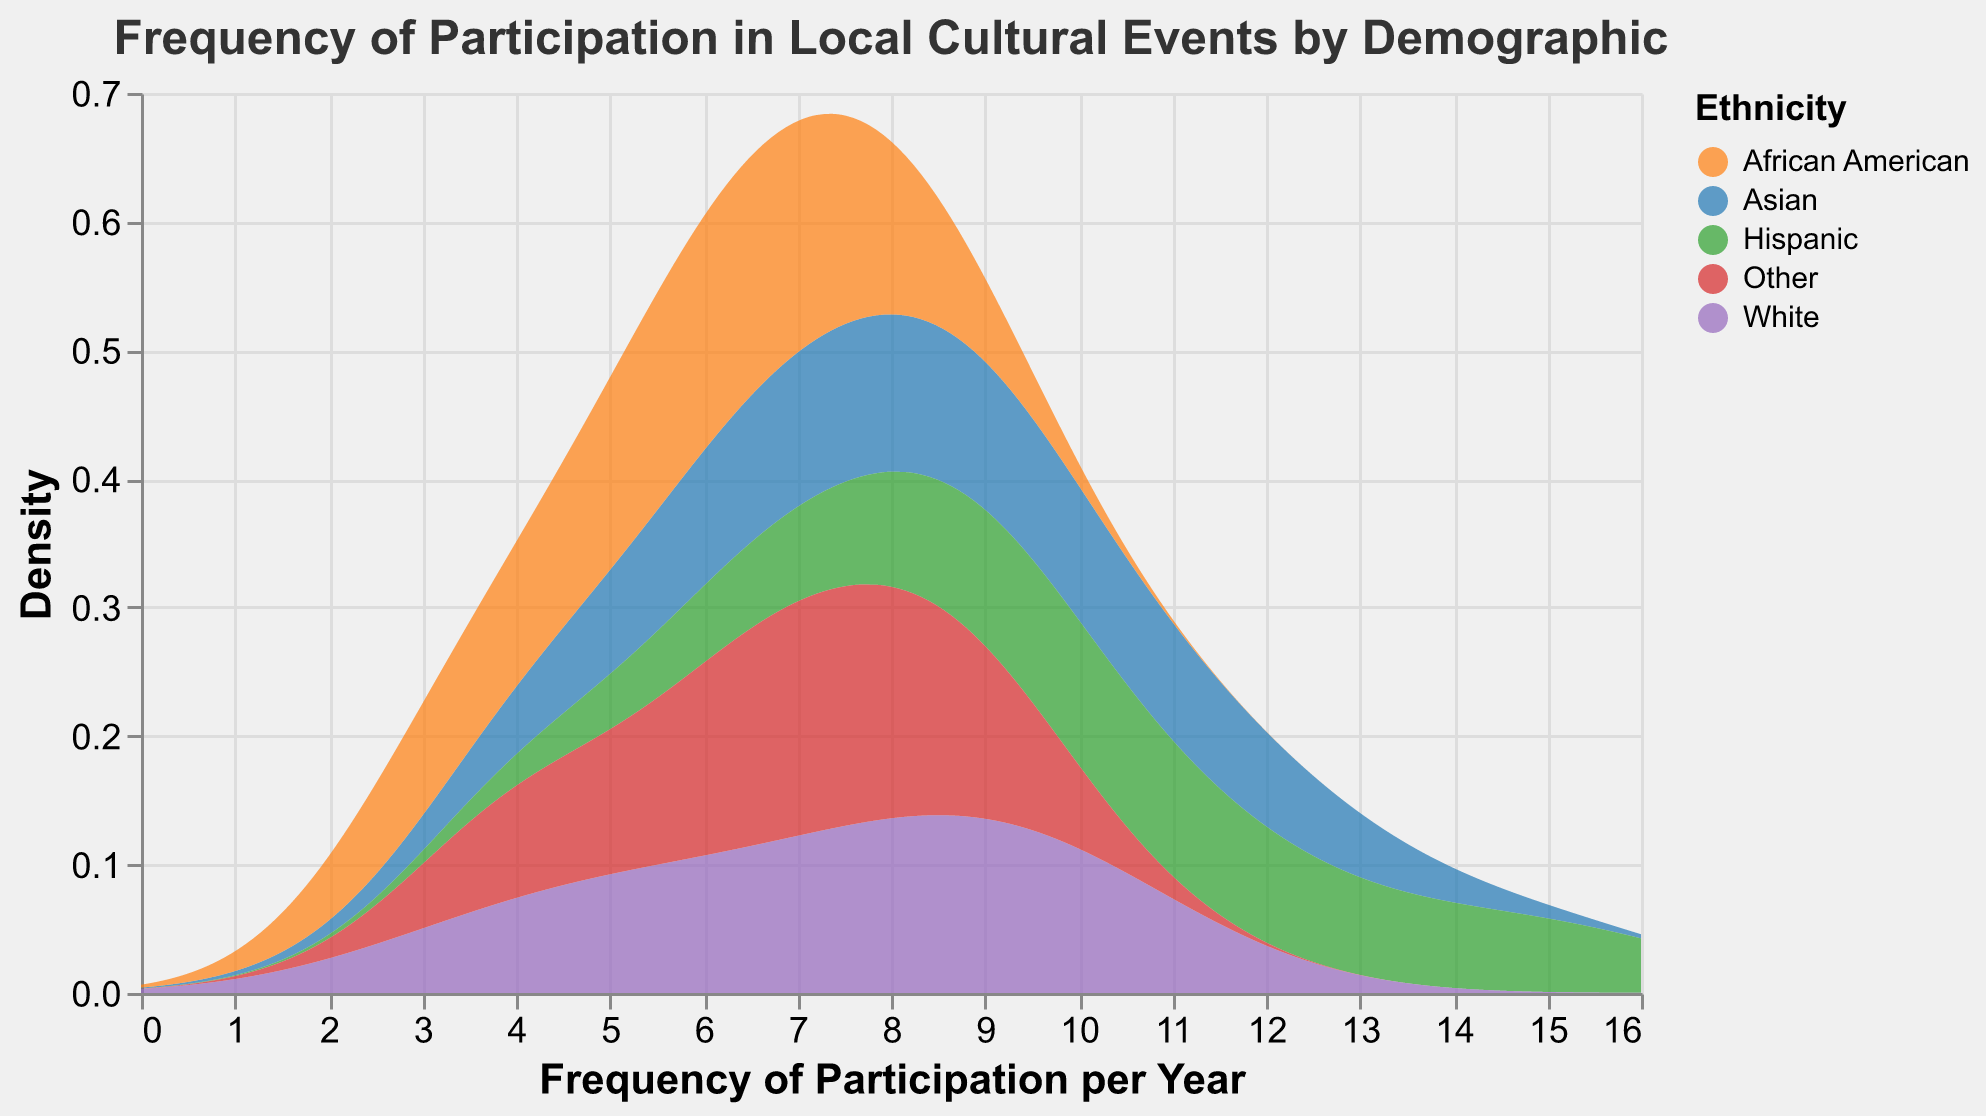What is the title of the plot? The title is at the top of the plot and reads "Frequency of Participation in Local Cultural Events by Demographic".
Answer: Frequency of Participation in Local Cultural Events by Demographic Which ethnic group appears to have the highest peak density in the plot? By examining the height of the peaks in the density plot, we can see that the Hispanic group has the highest peak density.
Answer: Hispanic What is the range of Frequency of Participation per Year shown on the x-axis? The x-axis represents "Frequency of Participation per Year," and the extent covers values from 0 to 16.
Answer: 0 to 16 How does the density distribution of African Americans differ from Asians in terms of frequency participation? The density distribution for African Americans peaks at a lower frequency and has generally lower density values compared to Asians, whose distribution peaks at a higher frequency.
Answer: African Americans peak lower than Asians Which age group shows the highest frequency of participation within the Hispanic ethnicity? By looking at the data points and their distribution in the plot, the age group 26-35 within the Hispanic ethnicity category shows the highest frequency of participation.
Answer: 26-35 Between which age groups is the decline in frequency of participation the steepest in the White ethnicity category? The data shows a significant drop-off between the 26-35 and the 36-45 age groups and then an even steeper decline between 46-60 and 61+.
Answer: 46-60 to 61+ What can you infer about the frequency of participation for those aged 61+ across all ethnicities? The plot shows that the density and frequency of participation for the 61+ age group are the lowest across all ethnicities, indicating reduced participation in this age group.
Answer: Lowest participation How do the distributions for the 'Other' ethnic group compare to the 'White' ethnic group? The 'Other' ethnic group has a somewhat similar distribution shape but generally lower peaks compared to the 'White' ethnic group, indicating slightly lower participation frequencies overall.
Answer: 'Other' has lower peaks than 'White' Among the age groups, which one shows the most uniform frequency of participation across different ethnicities? By analyzing the density plots, the 36-45 age group shows relatively uniform participation frequencies across different ethnicities, with no abrupt changes in density.
Answer: 36-45 